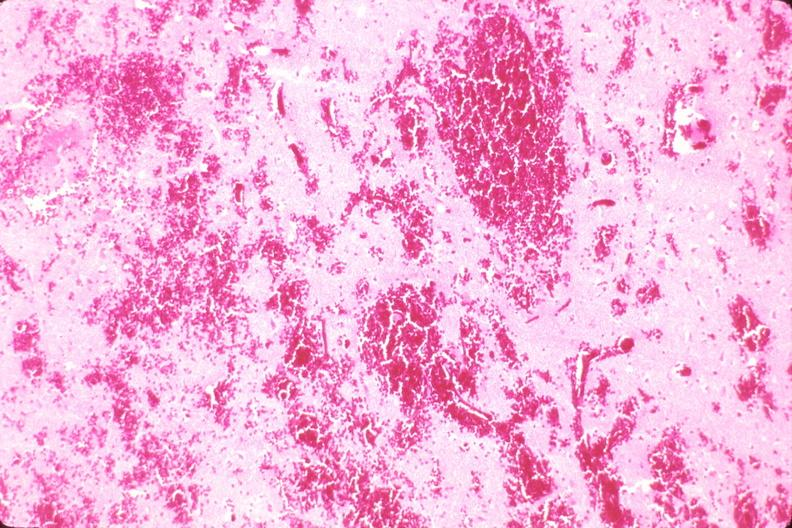what does this image show?
Answer the question using a single word or phrase. Brain 